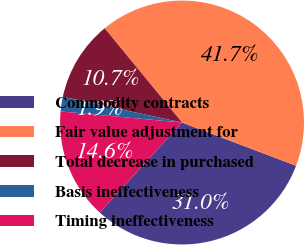<chart> <loc_0><loc_0><loc_500><loc_500><pie_chart><fcel>Commodity contracts<fcel>Fair value adjustment for<fcel>Total decrease in purchased<fcel>Basis ineffectiveness<fcel>Timing ineffectiveness<nl><fcel>31.03%<fcel>41.71%<fcel>10.67%<fcel>1.94%<fcel>14.65%<nl></chart> 